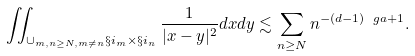Convert formula to latex. <formula><loc_0><loc_0><loc_500><loc_500>\iint _ { \cup _ { m , n \geq N , m \neq n } \S i _ { m } \times \S i _ { n } } \frac { 1 } { | x - y | ^ { 2 } } d x d y \lesssim \sum _ { n \geq N } n ^ { - ( d - 1 ) \ g a + 1 } .</formula> 